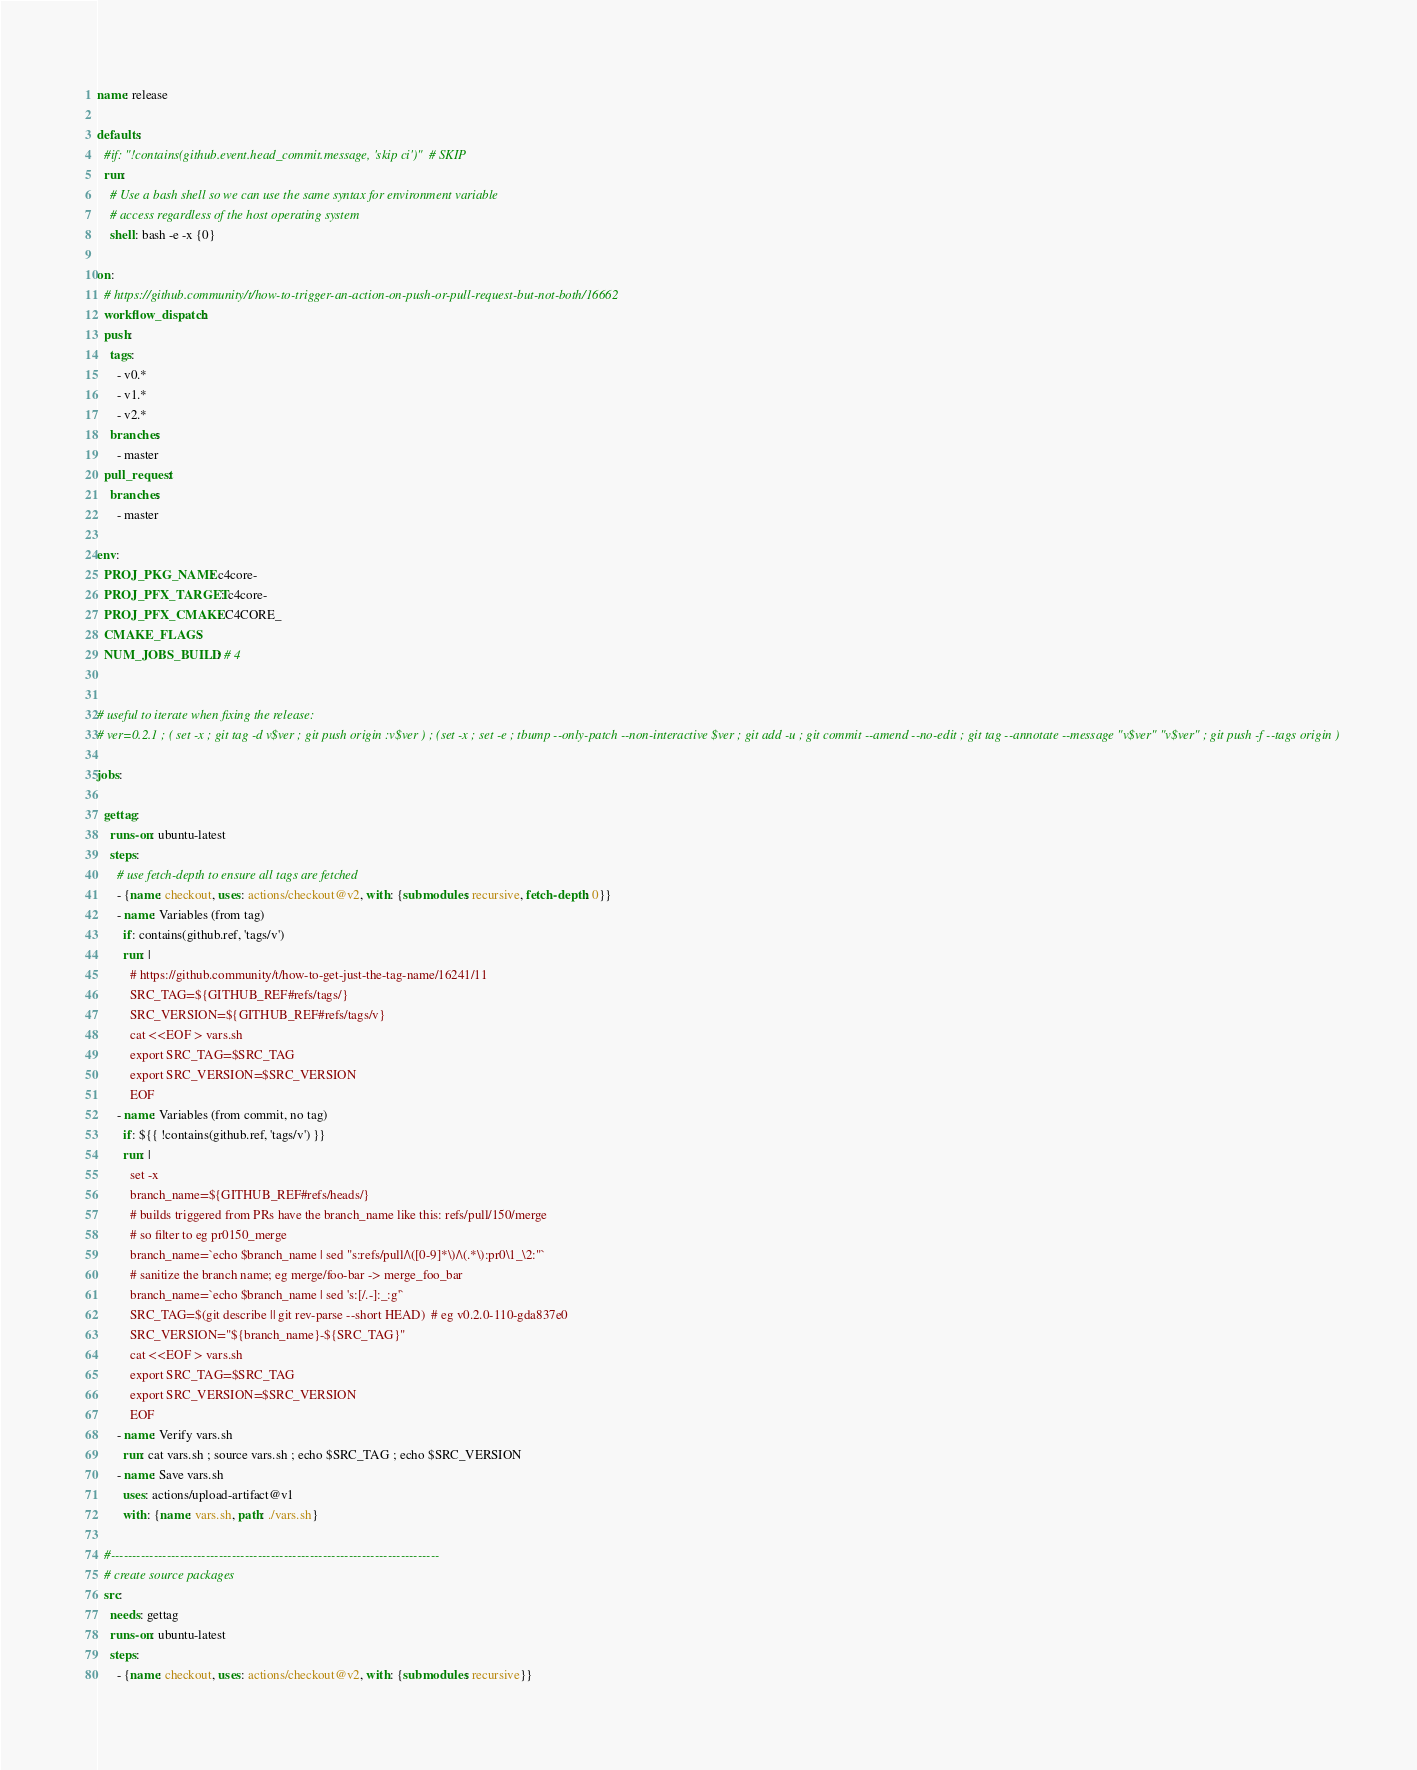<code> <loc_0><loc_0><loc_500><loc_500><_YAML_>name: release

defaults:
  #if: "!contains(github.event.head_commit.message, 'skip ci')"  # SKIP
  run:
    # Use a bash shell so we can use the same syntax for environment variable
    # access regardless of the host operating system
    shell: bash -e -x {0}

on:
  # https://github.community/t/how-to-trigger-an-action-on-push-or-pull-request-but-not-both/16662
  workflow_dispatch:
  push:
    tags:
      - v0.*
      - v1.*
      - v2.*
    branches:
      - master
  pull_request:
    branches:
      - master

env:
  PROJ_PKG_NAME: c4core-
  PROJ_PFX_TARGET: c4core-
  PROJ_PFX_CMAKE: C4CORE_
  CMAKE_FLAGS:
  NUM_JOBS_BUILD: # 4


# useful to iterate when fixing the release:
# ver=0.2.1 ; ( set -x ; git tag -d v$ver ; git push origin :v$ver ) ; (set -x ; set -e ; tbump --only-patch --non-interactive $ver ; git add -u ; git commit --amend --no-edit ; git tag --annotate --message "v$ver" "v$ver" ; git push -f --tags origin )

jobs:

  gettag:
    runs-on: ubuntu-latest
    steps:
      # use fetch-depth to ensure all tags are fetched
      - {name: checkout, uses: actions/checkout@v2, with: {submodules: recursive, fetch-depth: 0}}
      - name: Variables (from tag)
        if: contains(github.ref, 'tags/v')
        run: |
          # https://github.community/t/how-to-get-just-the-tag-name/16241/11
          SRC_TAG=${GITHUB_REF#refs/tags/}
          SRC_VERSION=${GITHUB_REF#refs/tags/v}
          cat <<EOF > vars.sh
          export SRC_TAG=$SRC_TAG
          export SRC_VERSION=$SRC_VERSION
          EOF
      - name: Variables (from commit, no tag)
        if: ${{ !contains(github.ref, 'tags/v') }}
        run: |
          set -x
          branch_name=${GITHUB_REF#refs/heads/}
          # builds triggered from PRs have the branch_name like this: refs/pull/150/merge
          # so filter to eg pr0150_merge
          branch_name=`echo $branch_name | sed "s:refs/pull/\([0-9]*\)/\(.*\):pr0\1_\2:"`
          # sanitize the branch name; eg merge/foo-bar -> merge_foo_bar
          branch_name=`echo $branch_name | sed 's:[/.-]:_:g'`
          SRC_TAG=$(git describe || git rev-parse --short HEAD)  # eg v0.2.0-110-gda837e0
          SRC_VERSION="${branch_name}-${SRC_TAG}"
          cat <<EOF > vars.sh
          export SRC_TAG=$SRC_TAG
          export SRC_VERSION=$SRC_VERSION
          EOF
      - name: Verify vars.sh
        run: cat vars.sh ; source vars.sh ; echo $SRC_TAG ; echo $SRC_VERSION
      - name: Save vars.sh
        uses: actions/upload-artifact@v1
        with: {name: vars.sh, path: ./vars.sh}

  #----------------------------------------------------------------------------
  # create source packages
  src:
    needs: gettag
    runs-on: ubuntu-latest
    steps:
      - {name: checkout, uses: actions/checkout@v2, with: {submodules: recursive}}</code> 